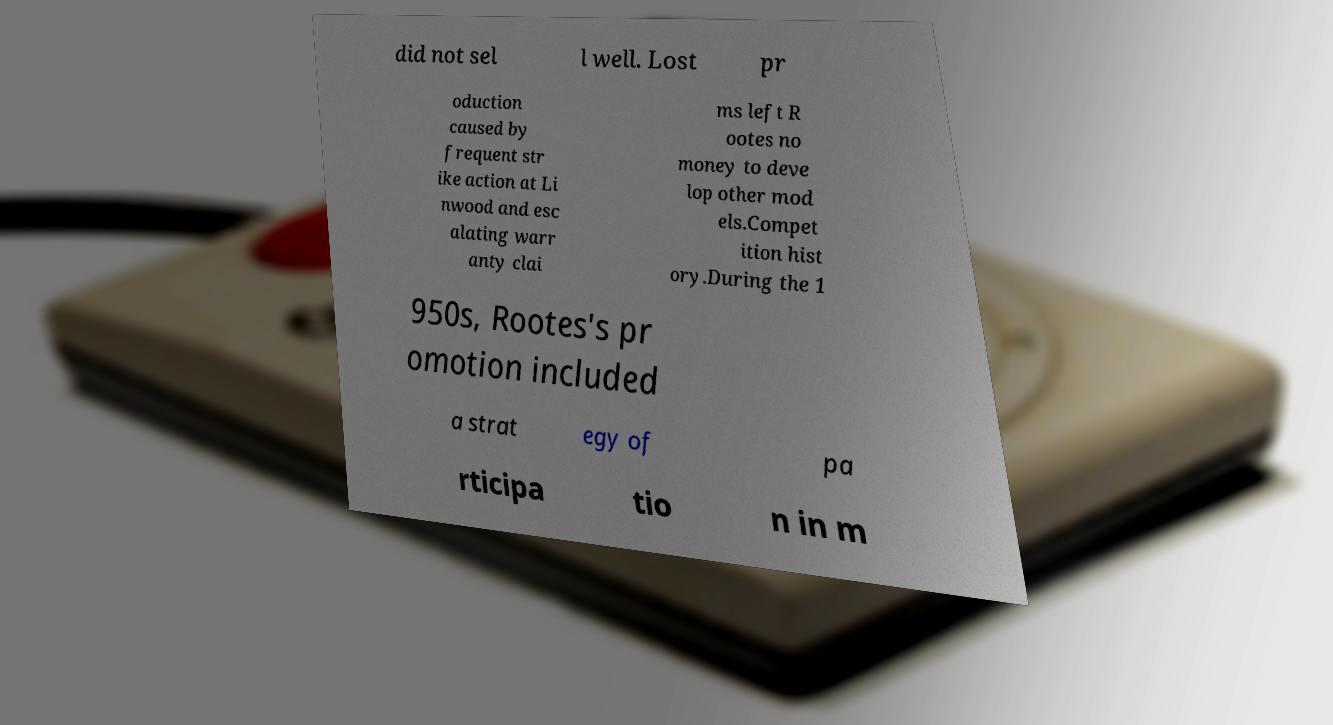Can you read and provide the text displayed in the image?This photo seems to have some interesting text. Can you extract and type it out for me? did not sel l well. Lost pr oduction caused by frequent str ike action at Li nwood and esc alating warr anty clai ms left R ootes no money to deve lop other mod els.Compet ition hist ory.During the 1 950s, Rootes's pr omotion included a strat egy of pa rticipa tio n in m 